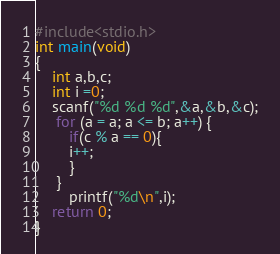Convert code to text. <code><loc_0><loc_0><loc_500><loc_500><_C_>#include<stdio.h>
int main(void)
{
	int a,b,c;
	int i =0;
	scanf("%d %d %d",&a,&b,&c);
	 for (a = a; a <= b; a++) {
	 	if(c % a == 0){
	 	i++;
	 	}
	 }
	 	printf("%d\n",i);
	return 0;
}</code> 